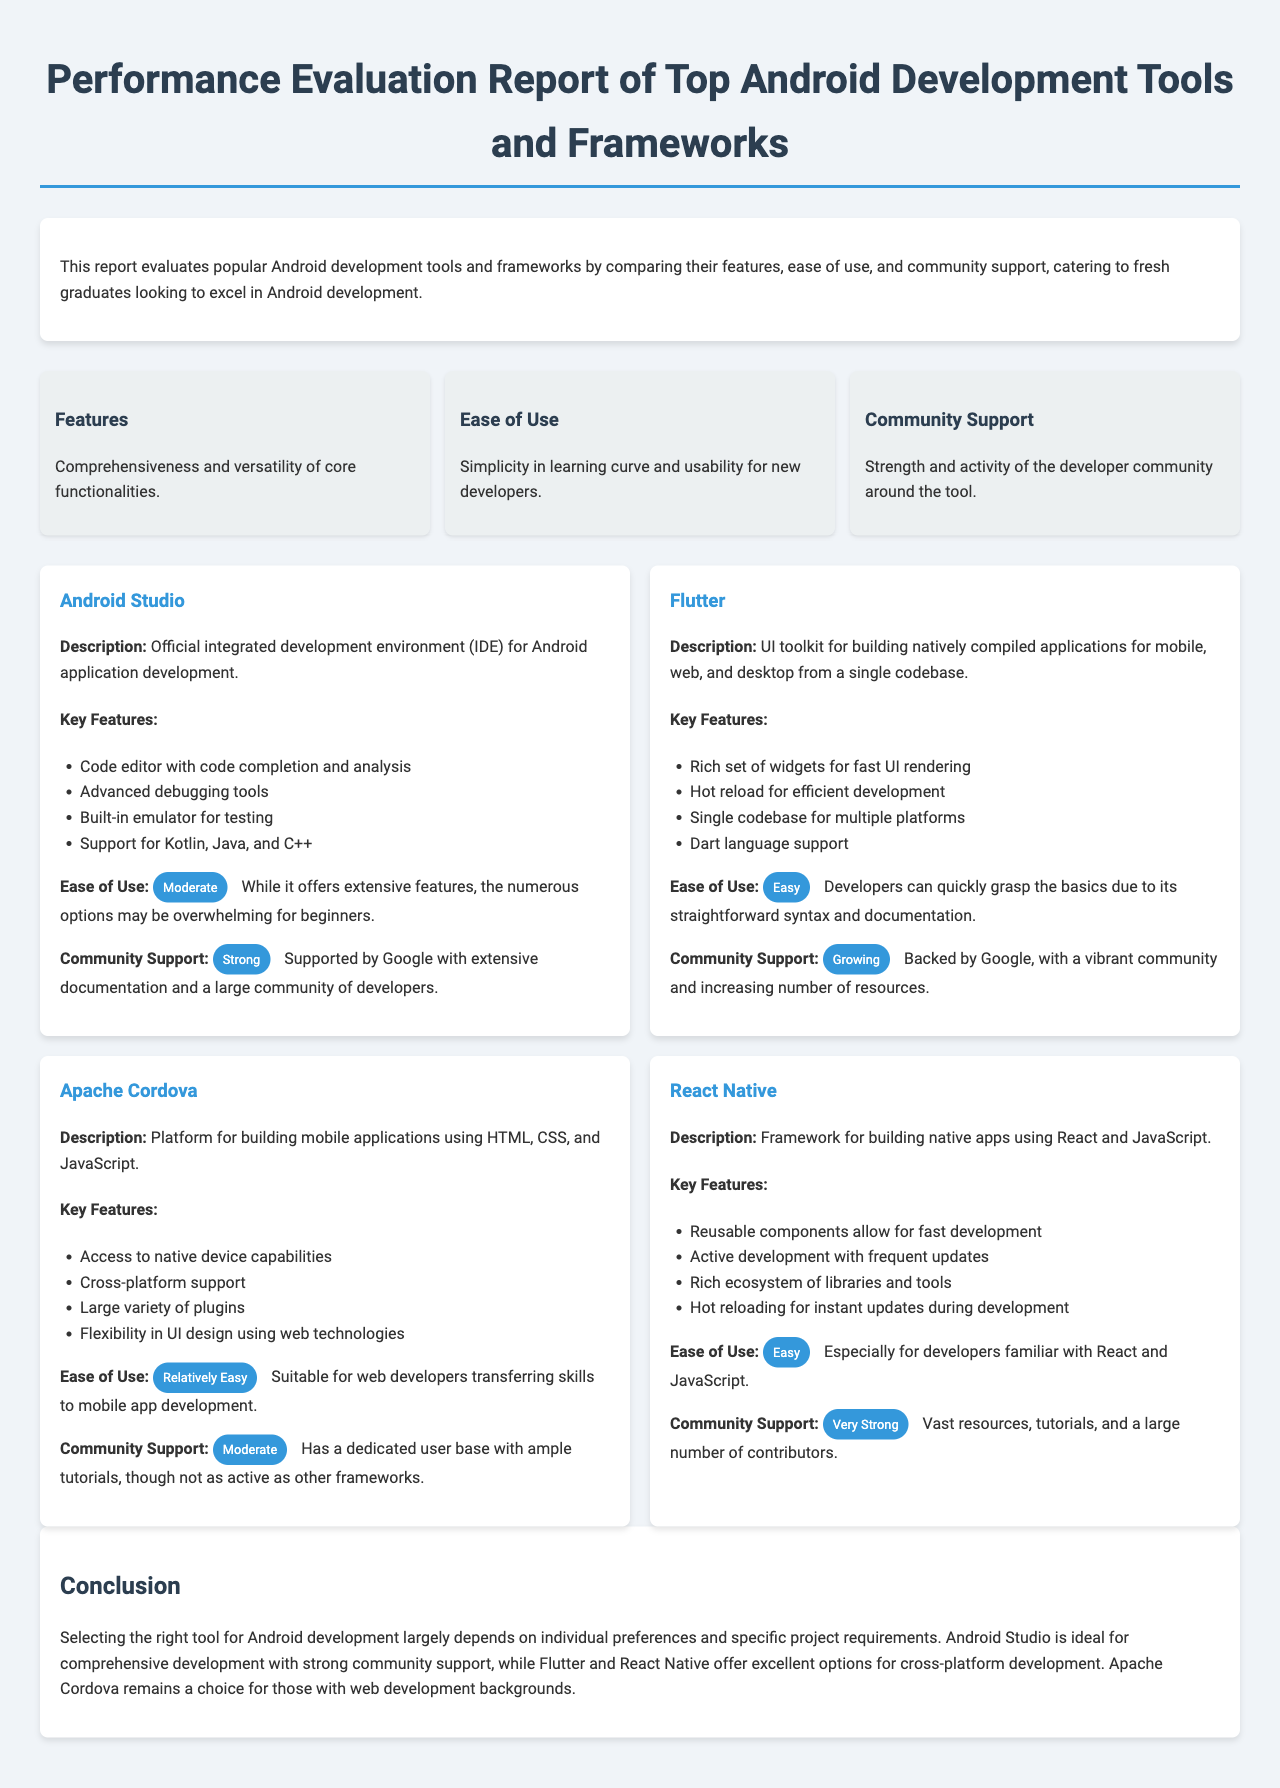What is the title of the report? The title of the report is displayed prominently at the top of the document.
Answer: Performance Evaluation Report of Top Android Development Tools and Frameworks How many criteria are used for evaluation? The criteria section of the document lists the three areas of evaluation specified.
Answer: 3 Which tool has "Moderate" ease of use? The ease of use section for each tool highlights their level of user-friendliness.
Answer: Android Studio What is the community support level for React Native? The community support section describes the level of support for each tool.
Answer: Very Strong Which framework supports Dart language? The key features listed under each framework specify the programming languages they support.
Answer: Flutter What is the primary focus of Apache Cordova? The description of Apache Cordova explains its main functionality.
Answer: Building mobile applications using HTML, CSS, and JavaScript Which tool is ideal for comprehensive development? The conclusion section summarizes the best use-case scenario for each tool.
Answer: Android Studio How does Flutter's ease of use rank? The ease of use information for Flutter denotes its user-friendliness level.
Answer: Easy 